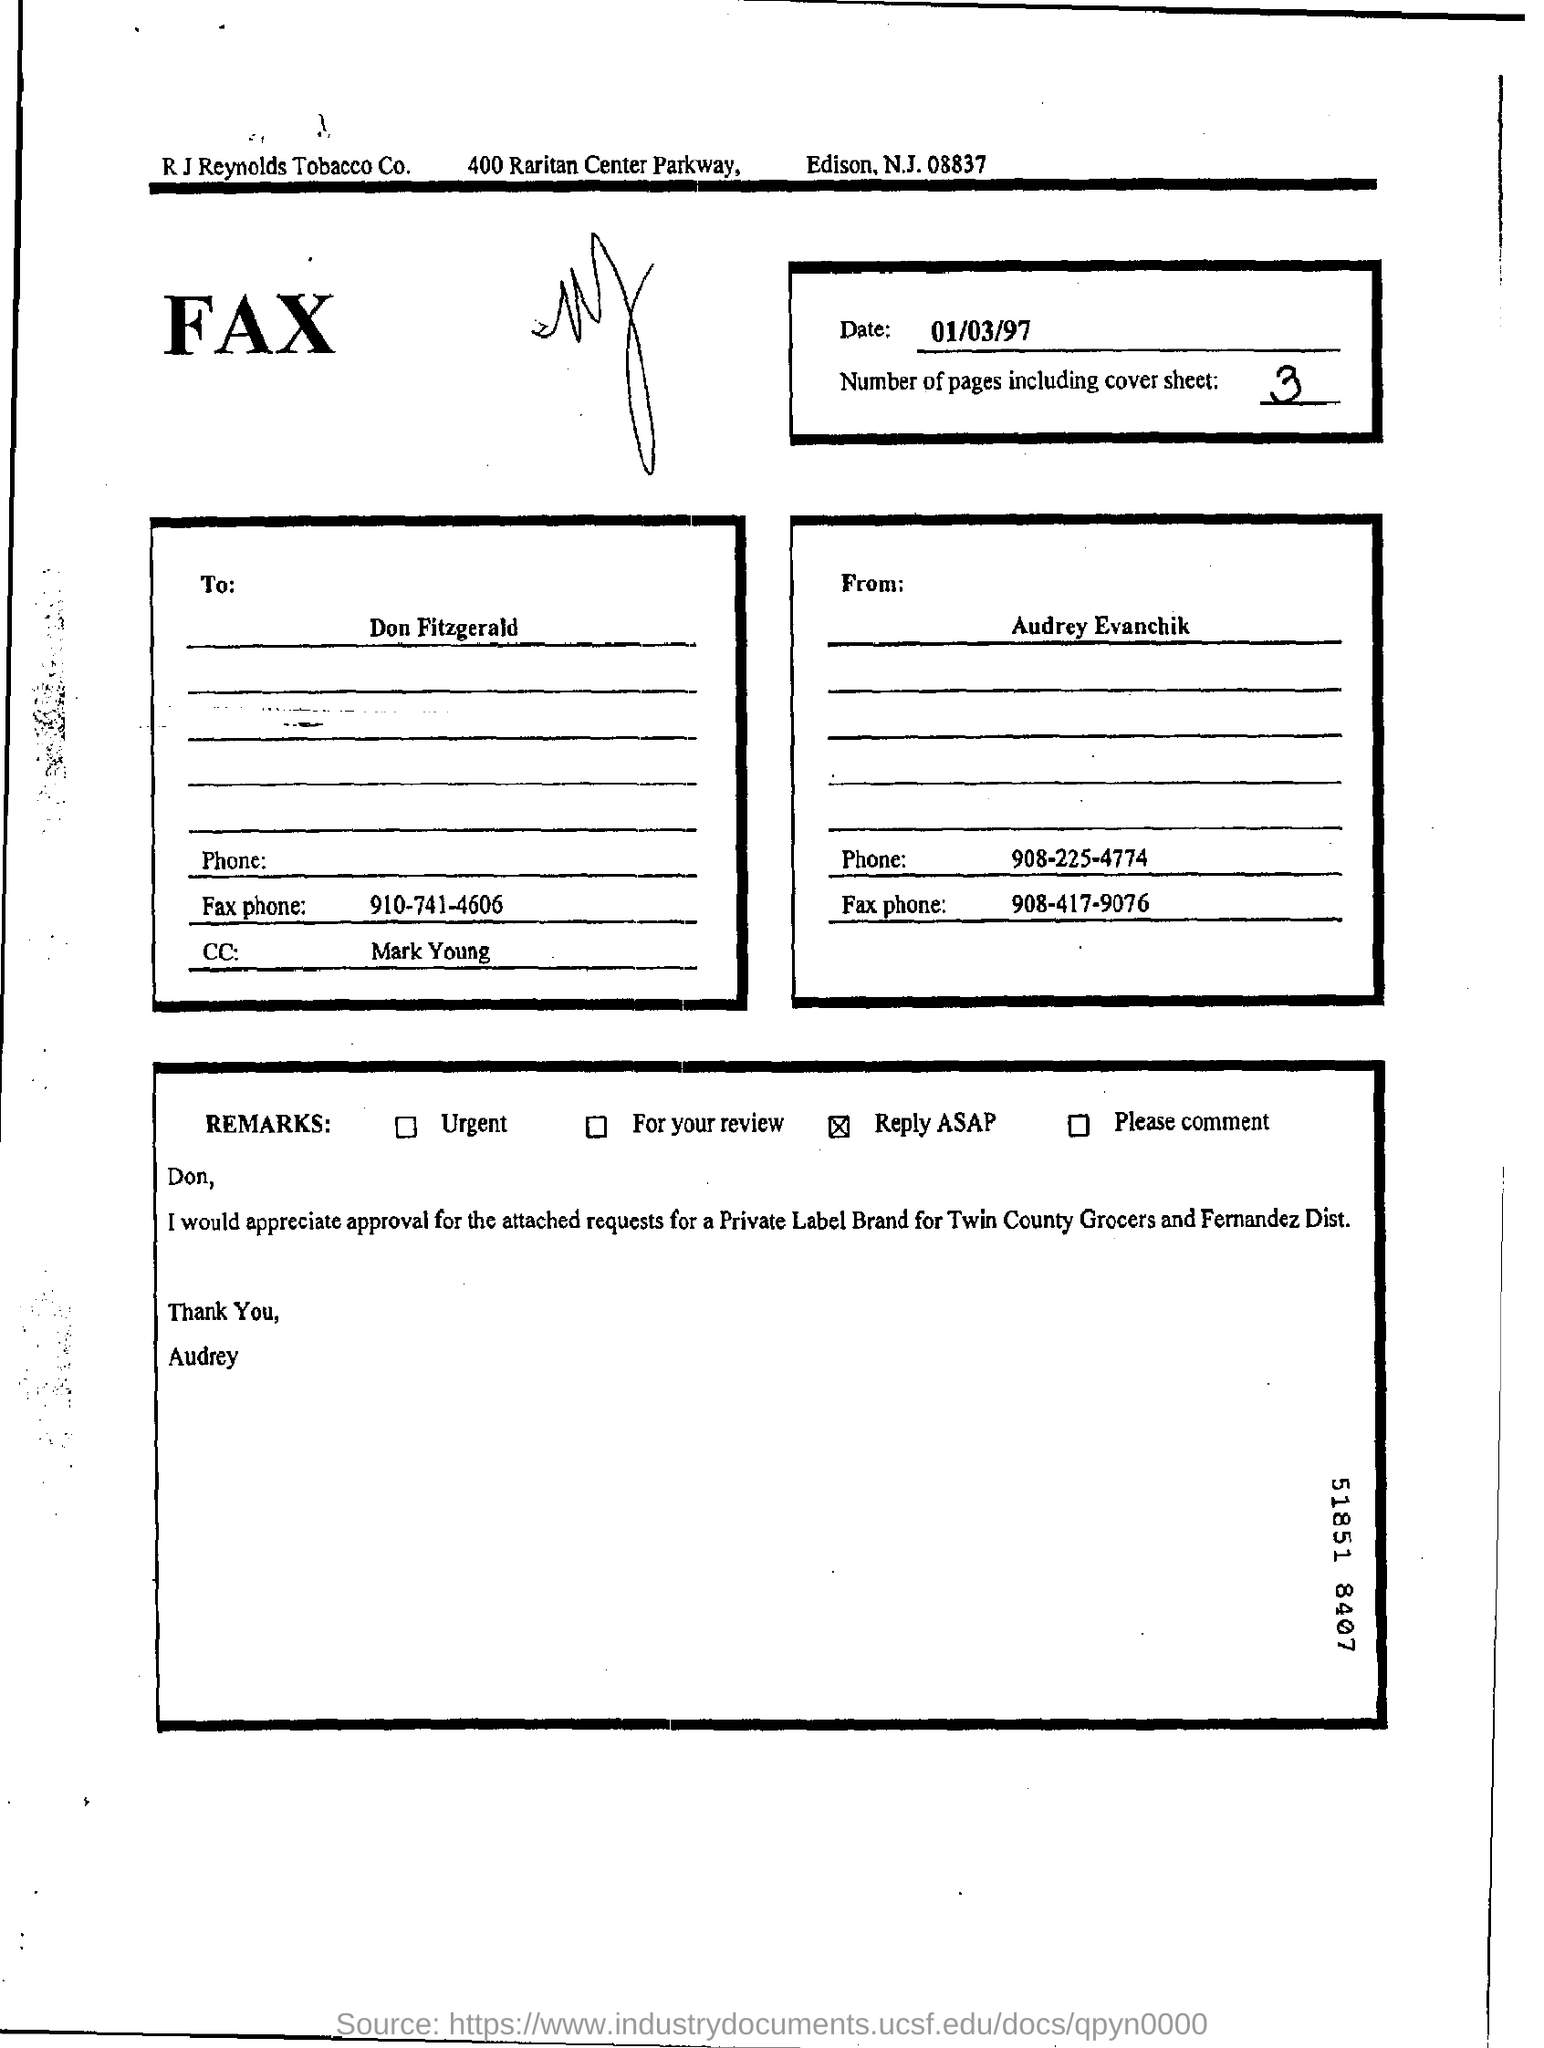What is the date of the fax?
Keep it short and to the point. 01/03/97. How many number of pages including cover sheet?
Provide a short and direct response. 3. Whos is this fax from?
Keep it short and to the point. Audrey Evanchik. What is Audrey's phone number?
Your answer should be very brief. 908-225-4774. Who is this fax sent to?
Provide a succinct answer. Don Fitzgerald. Under "Remarks" which option is selected?
Offer a terse response. Reply ASAP. 